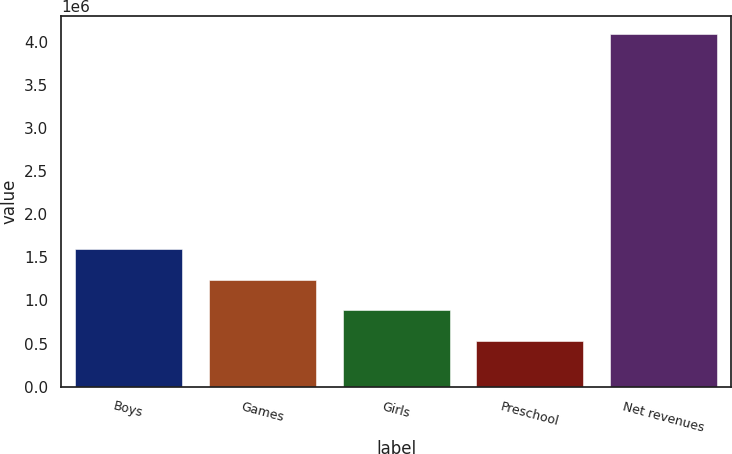Convert chart. <chart><loc_0><loc_0><loc_500><loc_500><bar_chart><fcel>Boys<fcel>Games<fcel>Girls<fcel>Preschool<fcel>Net revenues<nl><fcel>1.59601e+06<fcel>1.23987e+06<fcel>883730<fcel>527591<fcel>4.08898e+06<nl></chart> 